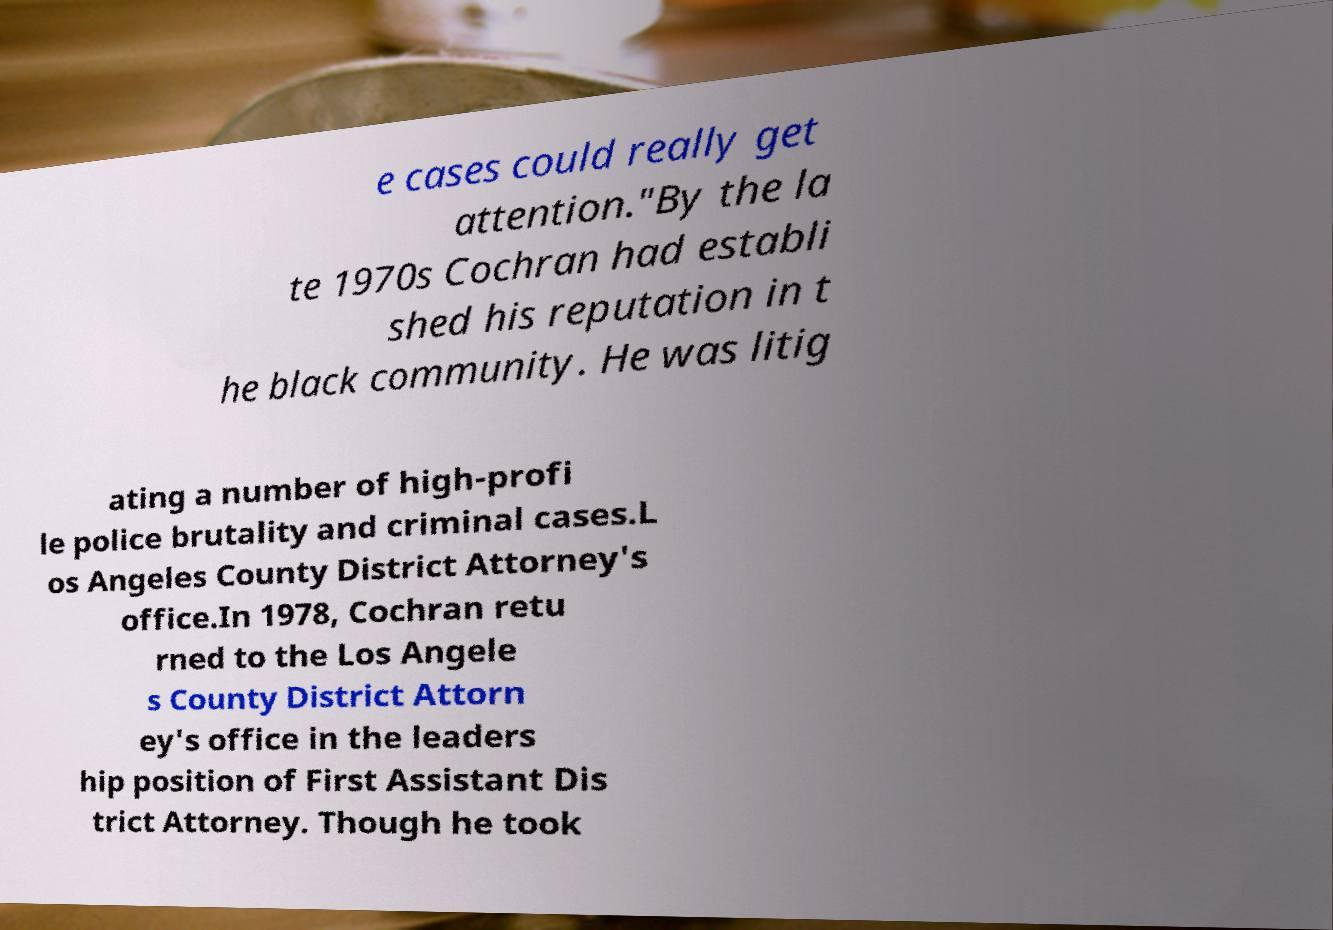For documentation purposes, I need the text within this image transcribed. Could you provide that? e cases could really get attention."By the la te 1970s Cochran had establi shed his reputation in t he black community. He was litig ating a number of high-profi le police brutality and criminal cases.L os Angeles County District Attorney's office.In 1978, Cochran retu rned to the Los Angele s County District Attorn ey's office in the leaders hip position of First Assistant Dis trict Attorney. Though he took 